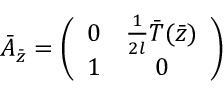Convert formula to latex. <formula><loc_0><loc_0><loc_500><loc_500>\bar { A } _ { \bar { z } } = \left ( \begin{array} { c c } { 0 } & { { { \frac { 1 } { 2 l } } \bar { T } ( \bar { z } ) } } \\ { 1 } & { 0 } \end{array} \right )</formula> 